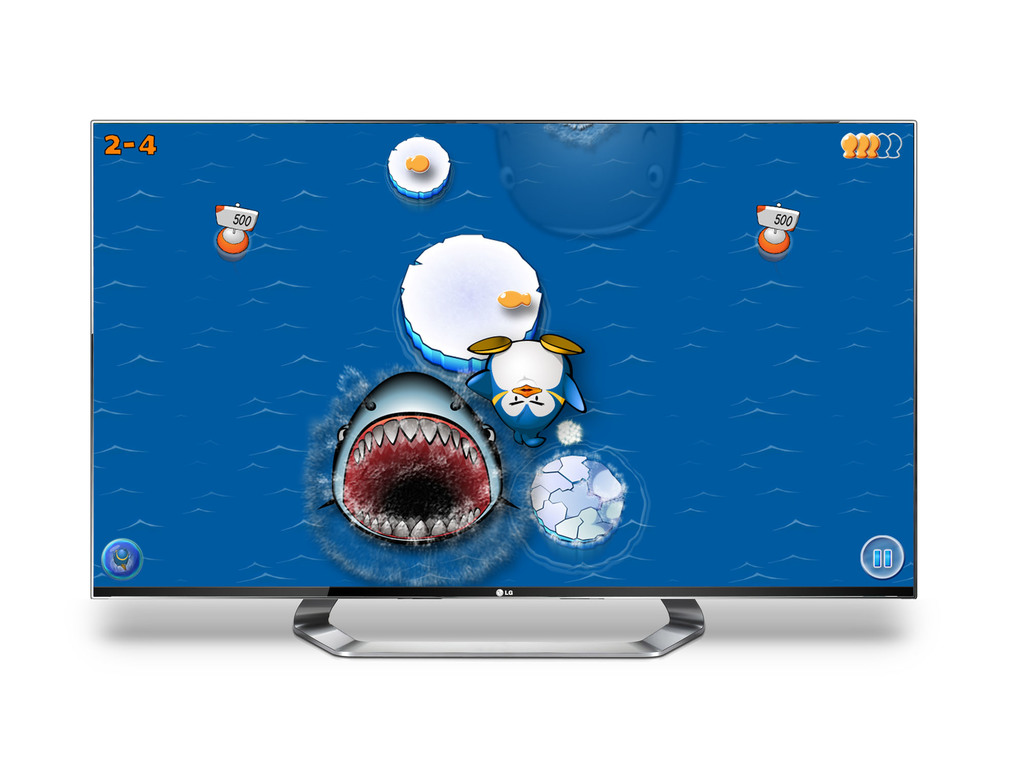Provide a one-sentence caption for the provided image. The image displays an animated computer game on an LG monitor, featuring adventurous sea-themed characters and interactive gameplay elements, enhancing a playful and engaging virtual environment. 